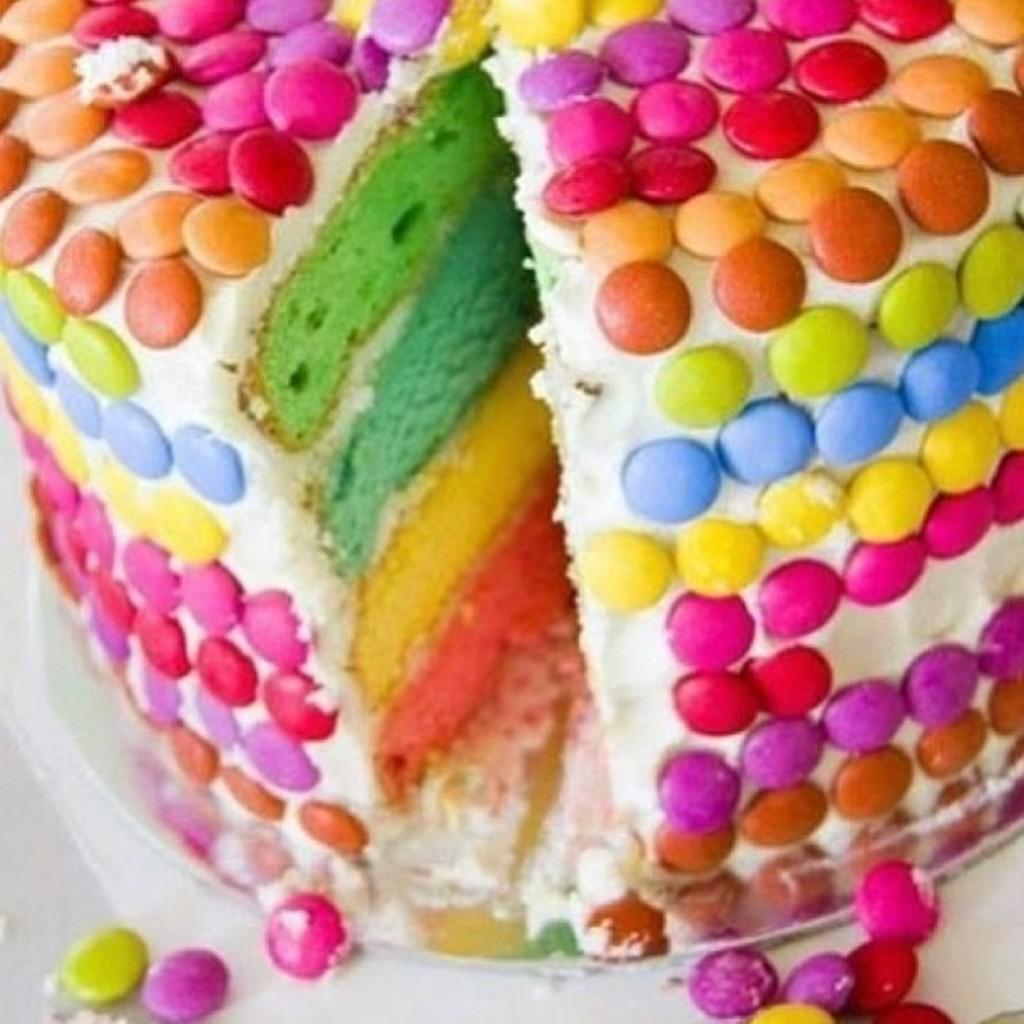What is the main feature of the cake in the image? There are many gems on the cake. How is the cake supported in the image? The cake is kept on a plate. Where is the plate with the cake located? The plate with the cake is kept on a table. Can you see someone kicking the sofa in the image? There is no sofa or kicking action present in the image. 